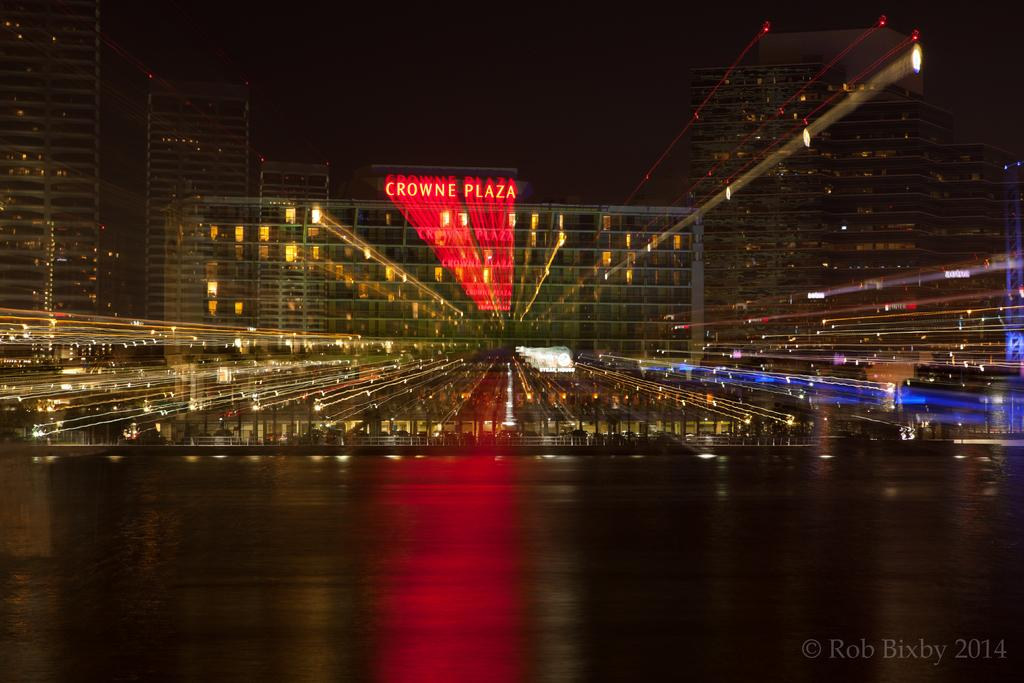What type of view is shown in the image? The image shows an outer view. How is the view being observed? The view is seen through a glass. What kind of structures can be seen in the image? There are multiple buildings visible in the image. Are there any illuminated elements in the image? Yes, lights are present in the image. What type of committee can be seen meeting in the image? There is no committee present in the image; it shows an outer view of buildings and lights. Is there a bear visible in the image? No, there is no bear present in the image. 